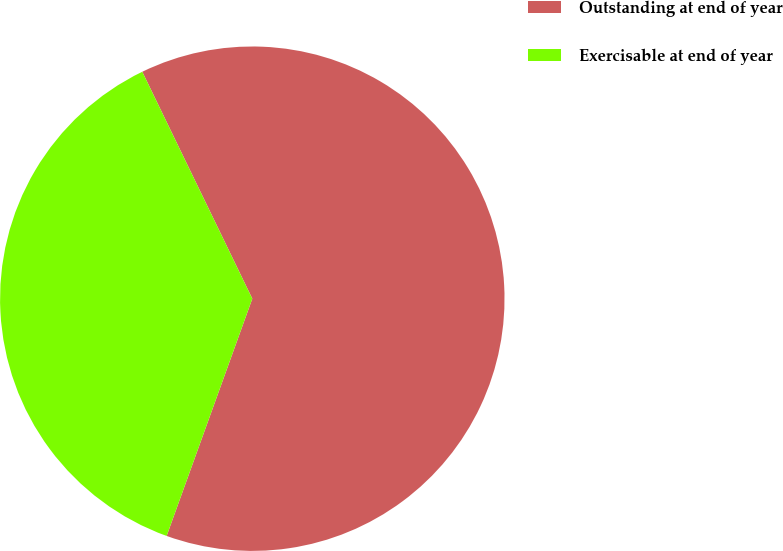Convert chart to OTSL. <chart><loc_0><loc_0><loc_500><loc_500><pie_chart><fcel>Outstanding at end of year<fcel>Exercisable at end of year<nl><fcel>62.7%<fcel>37.3%<nl></chart> 